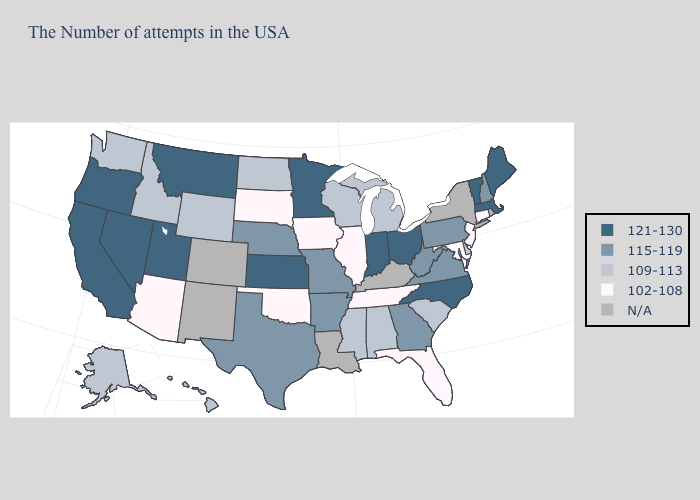What is the value of Montana?
Concise answer only. 121-130. Name the states that have a value in the range 115-119?
Concise answer only. New Hampshire, Pennsylvania, Virginia, West Virginia, Georgia, Missouri, Arkansas, Nebraska, Texas. What is the value of Florida?
Short answer required. 102-108. Name the states that have a value in the range 121-130?
Give a very brief answer. Maine, Massachusetts, Vermont, North Carolina, Ohio, Indiana, Minnesota, Kansas, Utah, Montana, Nevada, California, Oregon. What is the value of South Dakota?
Concise answer only. 102-108. What is the value of Georgia?
Answer briefly. 115-119. What is the value of Maine?
Keep it brief. 121-130. Among the states that border South Carolina , which have the lowest value?
Give a very brief answer. Georgia. Does the map have missing data?
Give a very brief answer. Yes. Among the states that border Massachusetts , which have the highest value?
Short answer required. Vermont. What is the value of Tennessee?
Give a very brief answer. 102-108. Name the states that have a value in the range 102-108?
Concise answer only. Connecticut, New Jersey, Maryland, Florida, Tennessee, Illinois, Iowa, Oklahoma, South Dakota, Arizona. What is the highest value in states that border Kentucky?
Keep it brief. 121-130. Which states have the lowest value in the South?
Give a very brief answer. Maryland, Florida, Tennessee, Oklahoma. What is the lowest value in states that border Kentucky?
Concise answer only. 102-108. 